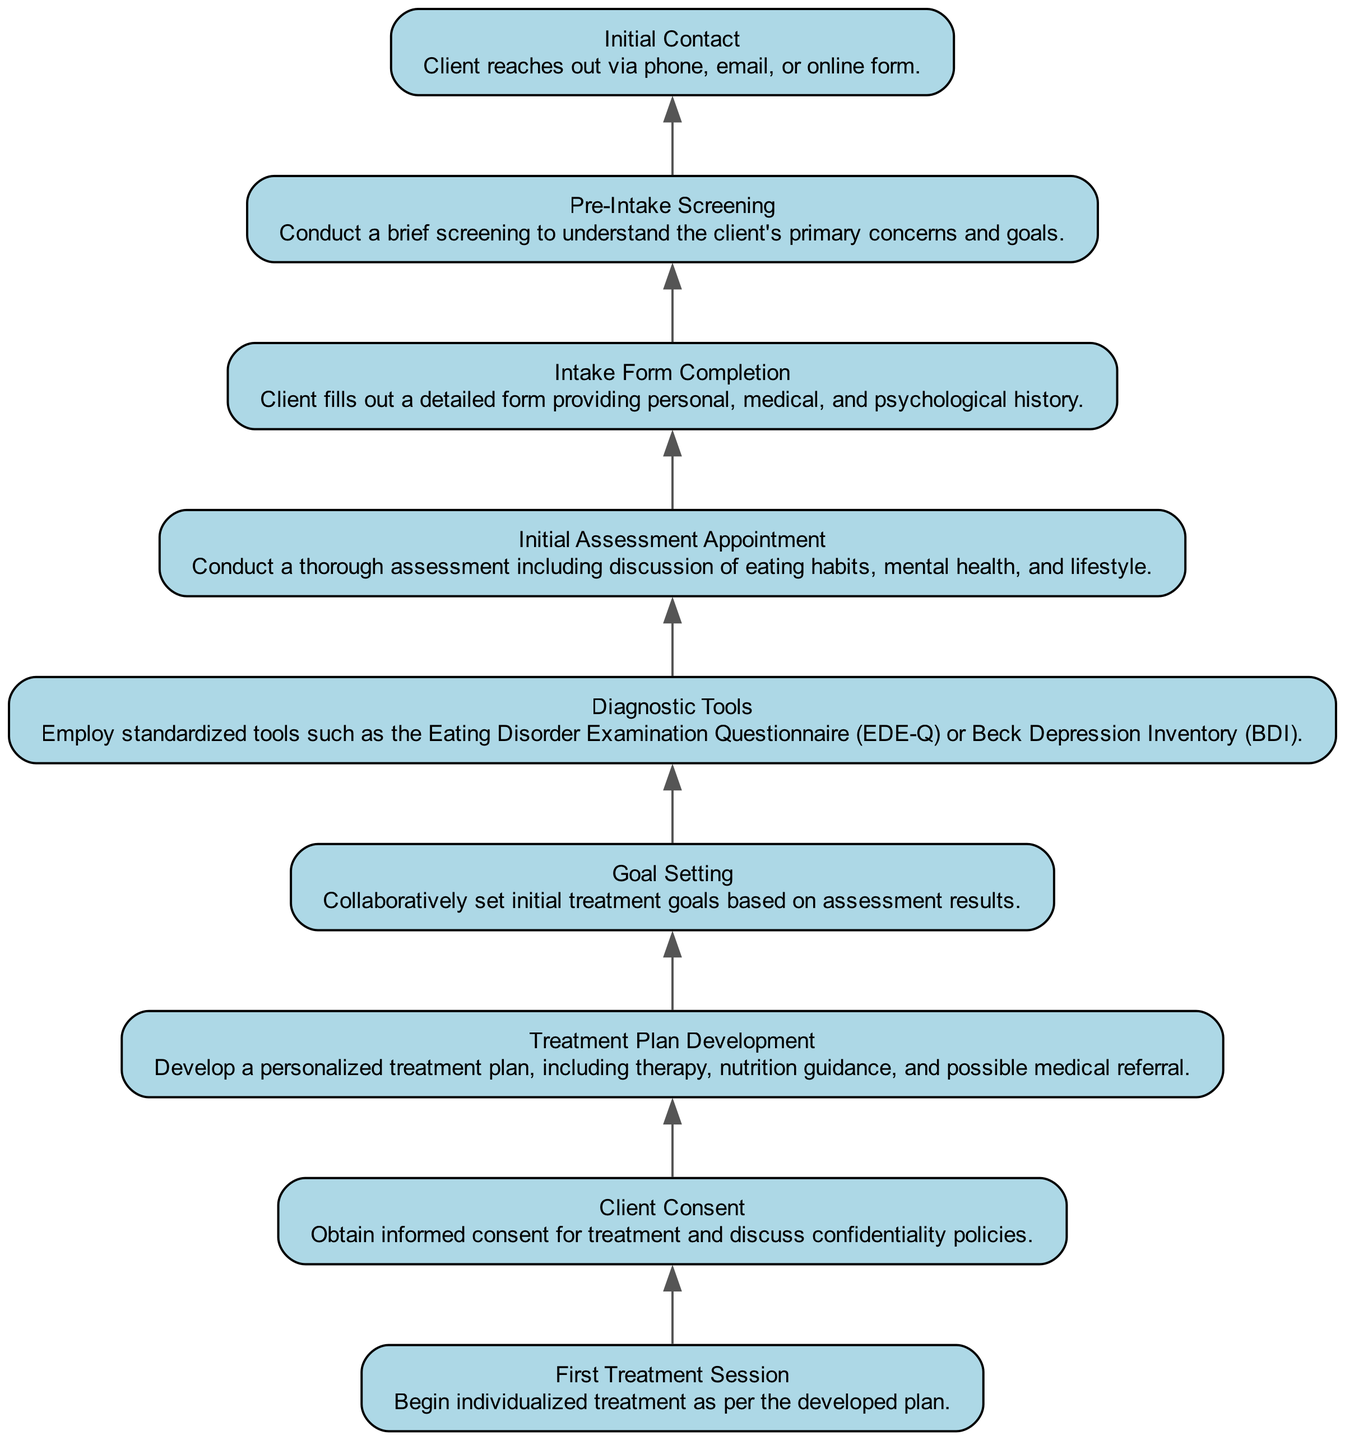What is the first step in the client intake process? The diagram shows "Initial Contact" at the bottom, which indicates it is the first step in the process when the client reaches out.
Answer: Initial Contact How many steps are there in the client intake process? By counting all the nodes in the diagram, there are a total of 9 steps outlined from "Initial Contact" to "First Treatment Session."
Answer: 9 What comes directly after the "Pre-Intake Screening" step? Referring to the diagram, "Intake Form Completion" follows immediately after "Pre-Intake Screening" as the next step in the process.
Answer: Intake Form Completion Which step involves setting treatment goals? The diagram indicates that "Goal Setting" is the step where initial treatment goals are collaboratively set based on assessment results.
Answer: Goal Setting What is the last step in the client intake process? The diagram shows that "First Treatment Session" is the last step in the process, where treatment begins.
Answer: First Treatment Session What are diagnostic tools used after? "Diagnostic Tools" are conducted after the "Initial Assessment Appointment," indicating a detailed assessment has occurred prior to using these tools.
Answer: Initial Assessment Appointment Which two steps are directly connected to "Client Consent"? The diagram shows that both "Goal Setting" and "Treatment Plan Development" are steps that come before "Client Consent," highlighting their connections.
Answer: Goal Setting and Treatment Plan Development What step immediately precedes "First Treatment Session"? Based on the flow of the diagram, "Client Consent" is the immediate step that occurs before "First Treatment Session" indicating the necessary consent must be obtained first.
Answer: Client Consent How does the flow from "Intake Form Completion" to "Initial Assessment Appointment" progress? The diagram illustrates that after the client completes the intake form, they move directly to the initial assessment appointment for a thorough evaluation.
Answer: Initial Assessment Appointment 